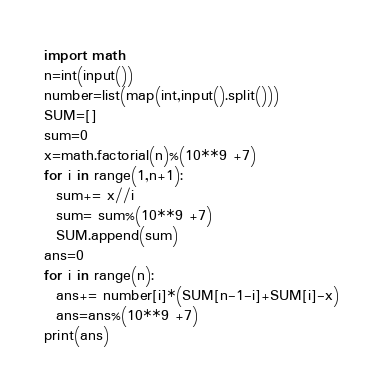<code> <loc_0><loc_0><loc_500><loc_500><_Python_>import math
n=int(input())
number=list(map(int,input().split()))
SUM=[]
sum=0
x=math.factorial(n)%(10**9 +7)
for i in range(1,n+1):
  sum+= x//i
  sum= sum%(10**9 +7)
  SUM.append(sum)
ans=0
for i in range(n):
  ans+= number[i]*(SUM[n-1-i]+SUM[i]-x)
  ans=ans%(10**9 +7)
print(ans)</code> 